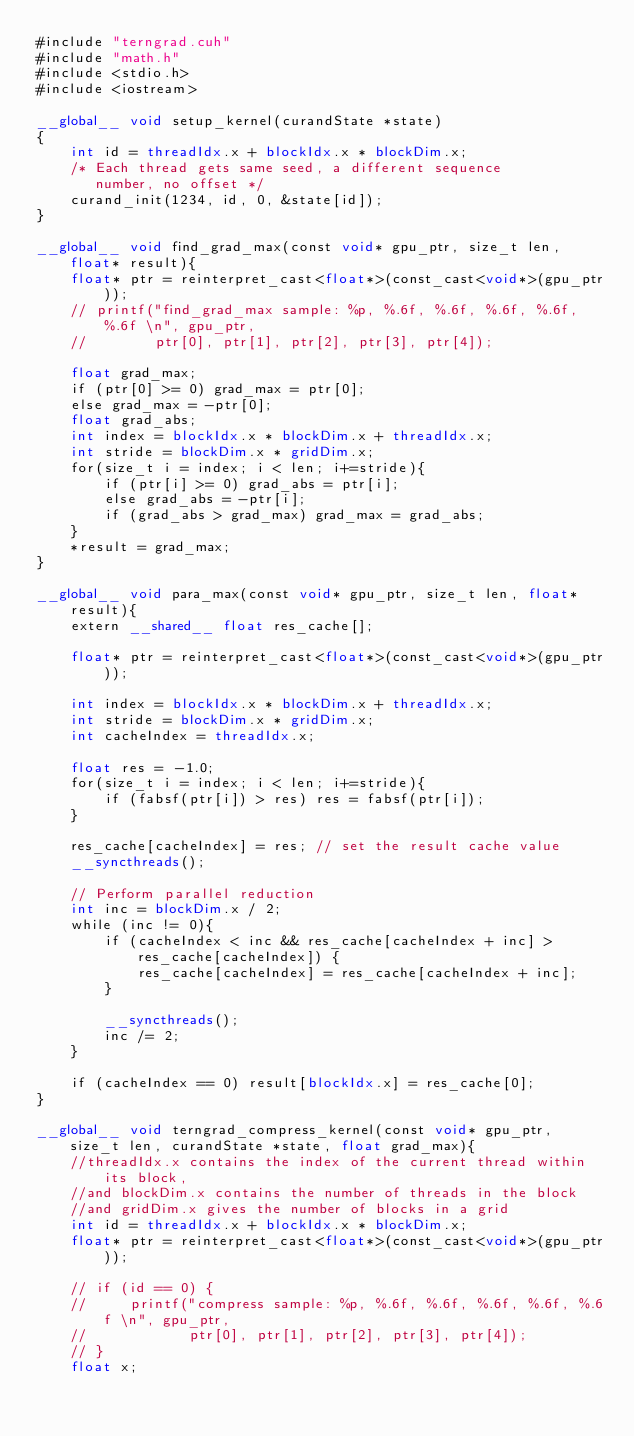Convert code to text. <code><loc_0><loc_0><loc_500><loc_500><_Cuda_>#include "terngrad.cuh"
#include "math.h"
#include <stdio.h>
#include <iostream>

__global__ void setup_kernel(curandState *state)
{
    int id = threadIdx.x + blockIdx.x * blockDim.x;
    /* Each thread gets same seed, a different sequence
       number, no offset */
    curand_init(1234, id, 0, &state[id]);
}

__global__ void find_grad_max(const void* gpu_ptr, size_t len, float* result){
    float* ptr = reinterpret_cast<float*>(const_cast<void*>(gpu_ptr));
    // printf("find_grad_max sample: %p, %.6f, %.6f, %.6f, %.6f, %.6f \n", gpu_ptr,
    //        ptr[0], ptr[1], ptr[2], ptr[3], ptr[4]);

    float grad_max;
    if (ptr[0] >= 0) grad_max = ptr[0];
    else grad_max = -ptr[0];
    float grad_abs;
    int index = blockIdx.x * blockDim.x + threadIdx.x;
    int stride = blockDim.x * gridDim.x;
    for(size_t i = index; i < len; i+=stride){
        if (ptr[i] >= 0) grad_abs = ptr[i];
        else grad_abs = -ptr[i];
        if (grad_abs > grad_max) grad_max = grad_abs;
    }
    *result = grad_max;
}

__global__ void para_max(const void* gpu_ptr, size_t len, float* result){
    extern __shared__ float res_cache[];

    float* ptr = reinterpret_cast<float*>(const_cast<void*>(gpu_ptr));

    int index = blockIdx.x * blockDim.x + threadIdx.x;
    int stride = blockDim.x * gridDim.x;
    int cacheIndex = threadIdx.x;

    float res = -1.0;
    for(size_t i = index; i < len; i+=stride){
        if (fabsf(ptr[i]) > res) res = fabsf(ptr[i]);
    }

    res_cache[cacheIndex] = res; // set the result cache value
    __syncthreads();

    // Perform parallel reduction
    int inc = blockDim.x / 2;
    while (inc != 0){
        if (cacheIndex < inc && res_cache[cacheIndex + inc] > res_cache[cacheIndex]) {
            res_cache[cacheIndex] = res_cache[cacheIndex + inc];
        }

        __syncthreads();
        inc /= 2;
    }

    if (cacheIndex == 0) result[blockIdx.x] = res_cache[0];
}

__global__ void terngrad_compress_kernel(const void* gpu_ptr, size_t len, curandState *state, float grad_max){
    //threadIdx.x contains the index of the current thread within its block, 
    //and blockDim.x contains the number of threads in the block
    //and gridDim.x gives the number of blocks in a grid
    int id = threadIdx.x + blockIdx.x * blockDim.x;
    float* ptr = reinterpret_cast<float*>(const_cast<void*>(gpu_ptr));
    
    // if (id == 0) {
    //     printf("compress sample: %p, %.6f, %.6f, %.6f, %.6f, %.6f \n", gpu_ptr,
    //            ptr[0], ptr[1], ptr[2], ptr[3], ptr[4]);
    // }
    float x;</code> 